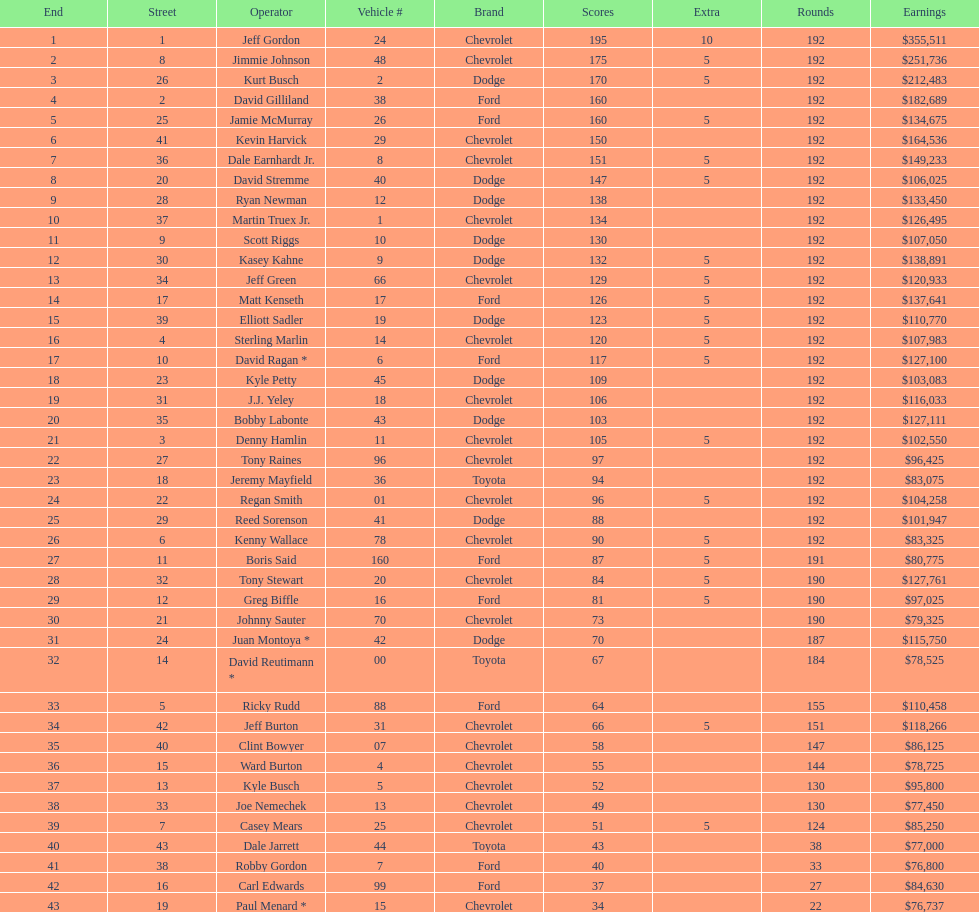What was jimmie johnson's winnings? $251,736. 